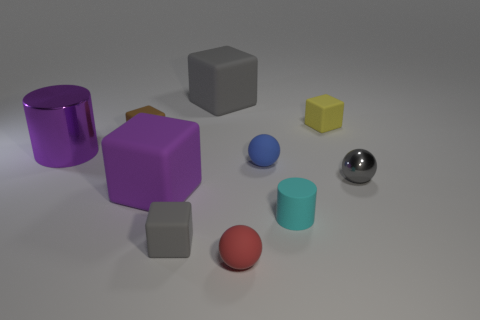There is another large object that is the same color as the large metal object; what shape is it?
Ensure brevity in your answer.  Cube. There is a purple rubber block; does it have the same size as the gray rubber cube that is behind the big purple metallic thing?
Offer a terse response. Yes. What color is the small rubber object that is left of the large gray matte cube and in front of the gray metal object?
Ensure brevity in your answer.  Gray. Is the number of large objects that are behind the metal cylinder greater than the number of large gray blocks to the right of the red matte object?
Offer a very short reply. Yes. There is a cyan thing that is made of the same material as the tiny yellow thing; what size is it?
Offer a very short reply. Small. There is a shiny object that is left of the small gray cube; how many big things are behind it?
Give a very brief answer. 1. Are there any other objects that have the same shape as the blue matte object?
Provide a succinct answer. Yes. The large rubber thing left of the gray block in front of the small yellow rubber block is what color?
Provide a short and direct response. Purple. Is the number of purple shiny cylinders greater than the number of cyan metallic objects?
Your answer should be very brief. Yes. What number of purple matte objects have the same size as the brown rubber cube?
Keep it short and to the point. 0. 